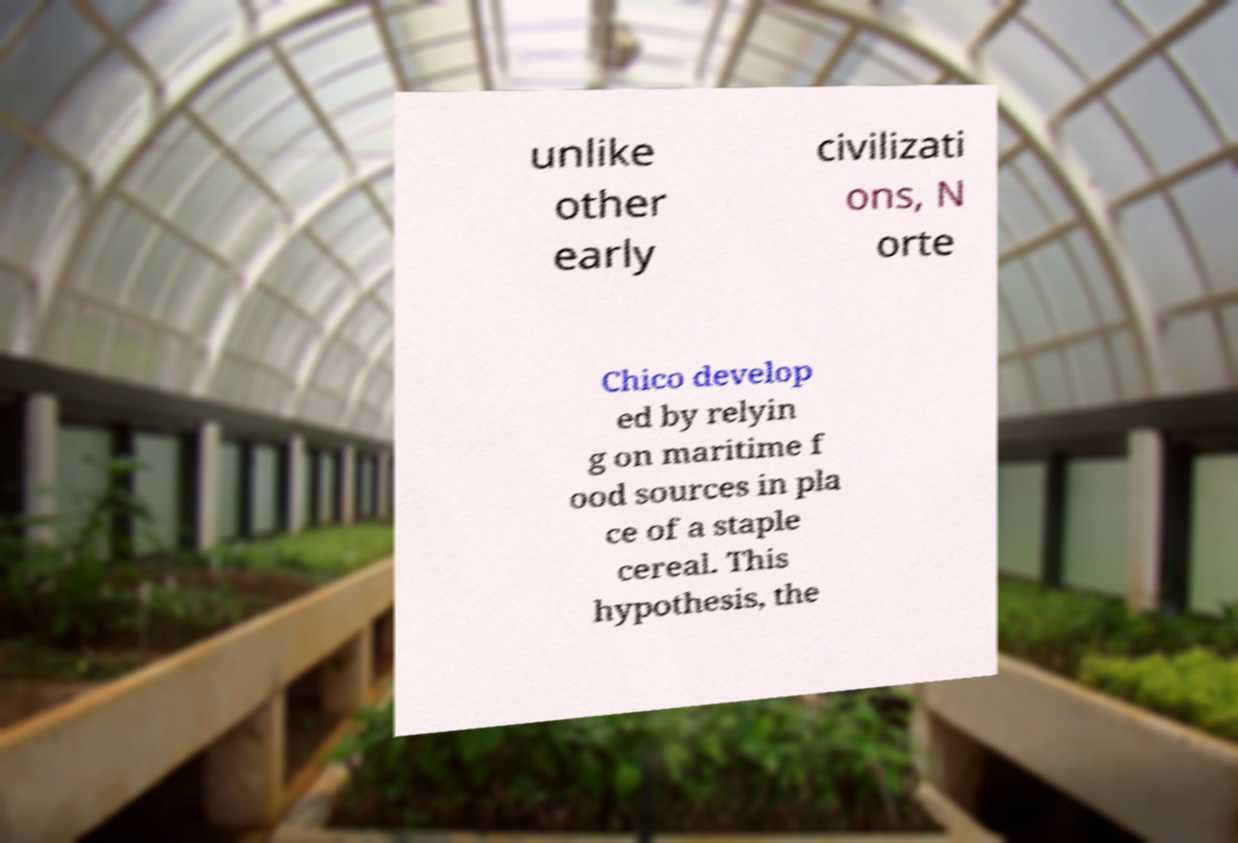Please read and relay the text visible in this image. What does it say? unlike other early civilizati ons, N orte Chico develop ed by relyin g on maritime f ood sources in pla ce of a staple cereal. This hypothesis, the 